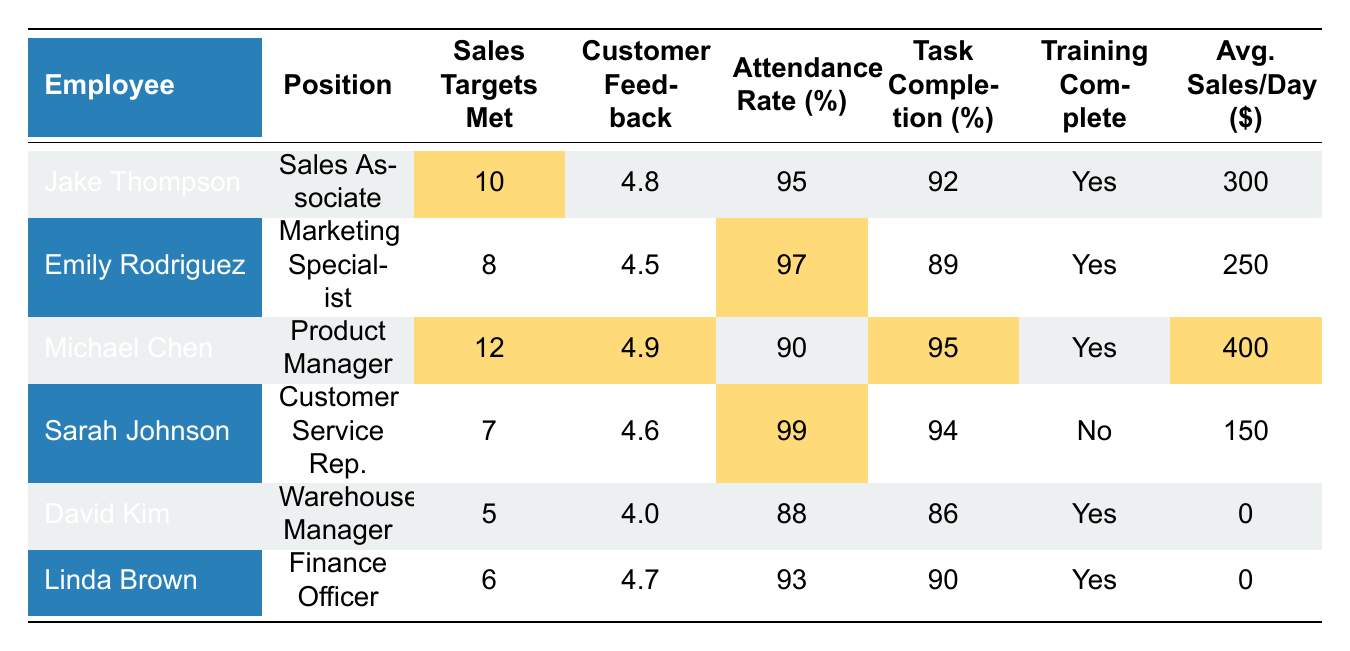What is the customer feedback score for Jake Thompson? Looking at the table, the customer feedback score listed for Jake Thompson is 4.8.
Answer: 4.8 How many sales targets did Michael Chen meet? The table indicates that Michael Chen met 12 sales targets.
Answer: 12 What is the attendance rate for Sarah Johnson? Based on the table, Sarah Johnson has an attendance rate of 99%.
Answer: 99% Which employee has the highest average sales per day? By comparing the average sales per day of each employee, Michael Chen has the highest at \$400.
Answer: Michael Chen Did Emily Rodriguez complete her training? The training completion status for Emily Rodriguez in the table shows "Yes," indicating she completed her training.
Answer: Yes What is the average attendance rate of all employees? To find the average attendance rate, sum the attendance rates (95 + 97 + 90 + 99 + 88 + 93 = 562) and divide by the number of employees (6): 562 / 6 = 93.67.
Answer: 93.67 How many employees have a customer feedback score above 4.5? The scores above 4.5 are for Jake Thompson (4.8), Michael Chen (4.9), Sarah Johnson (4.6), and Linda Brown (4.7), making a total of 4 employees.
Answer: 4 Which employee has the lowest task completion rate? The task completion rates listed are: 92 (Jake), 89 (Emily), 95 (Michael), 94 (Sarah), 86 (David), and 90 (Linda). David Kim has the lowest at 86%.
Answer: David Kim What is the total number of sales targets met by all employees? The total sales targets met is calculated by adding them together: (10 + 8 + 12 + 7 + 5 + 6 = 48).
Answer: 48 Is there an employee who did not meet any sales targets? Looking at the table, David Kim and Linda Brown both have an average sales per day of 0, indicating they likely did not meet any sales targets. So, the answer is "Yes."
Answer: Yes 